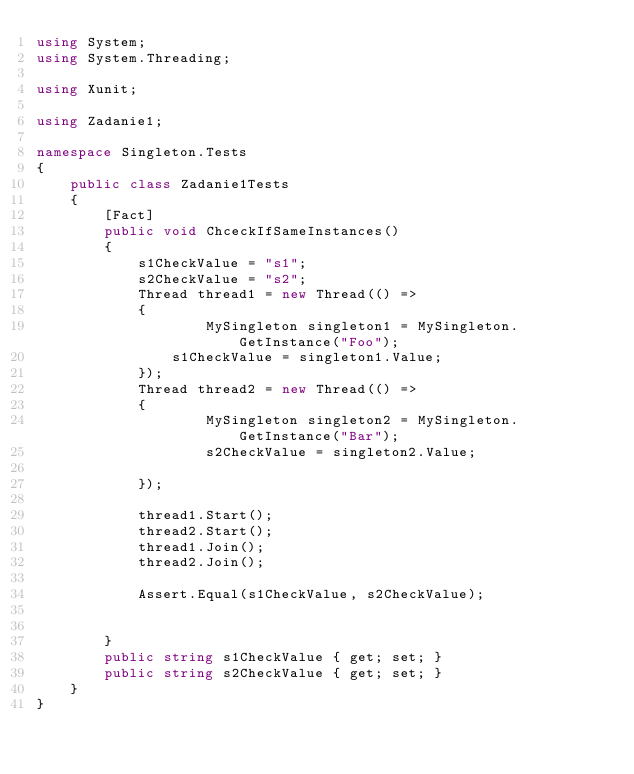Convert code to text. <code><loc_0><loc_0><loc_500><loc_500><_C#_>using System;
using System.Threading;

using Xunit;

using Zadanie1;

namespace Singleton.Tests
{
    public class Zadanie1Tests
    {
        [Fact]
        public void ChceckIfSameInstances()
        {
            s1CheckValue = "s1";
            s2CheckValue = "s2";
            Thread thread1 = new Thread(() =>
            {
                    MySingleton singleton1 = MySingleton.GetInstance("Foo");
                s1CheckValue = singleton1.Value;
            });
            Thread thread2 = new Thread(() =>
            {
                    MySingleton singleton2 = MySingleton.GetInstance("Bar");
                    s2CheckValue = singleton2.Value;

            });

            thread1.Start();
            thread2.Start();
            thread1.Join();
            thread2.Join();

            Assert.Equal(s1CheckValue, s2CheckValue);            
            
          
        }
        public string s1CheckValue { get; set; }
        public string s2CheckValue { get; set; }
    }
}
</code> 